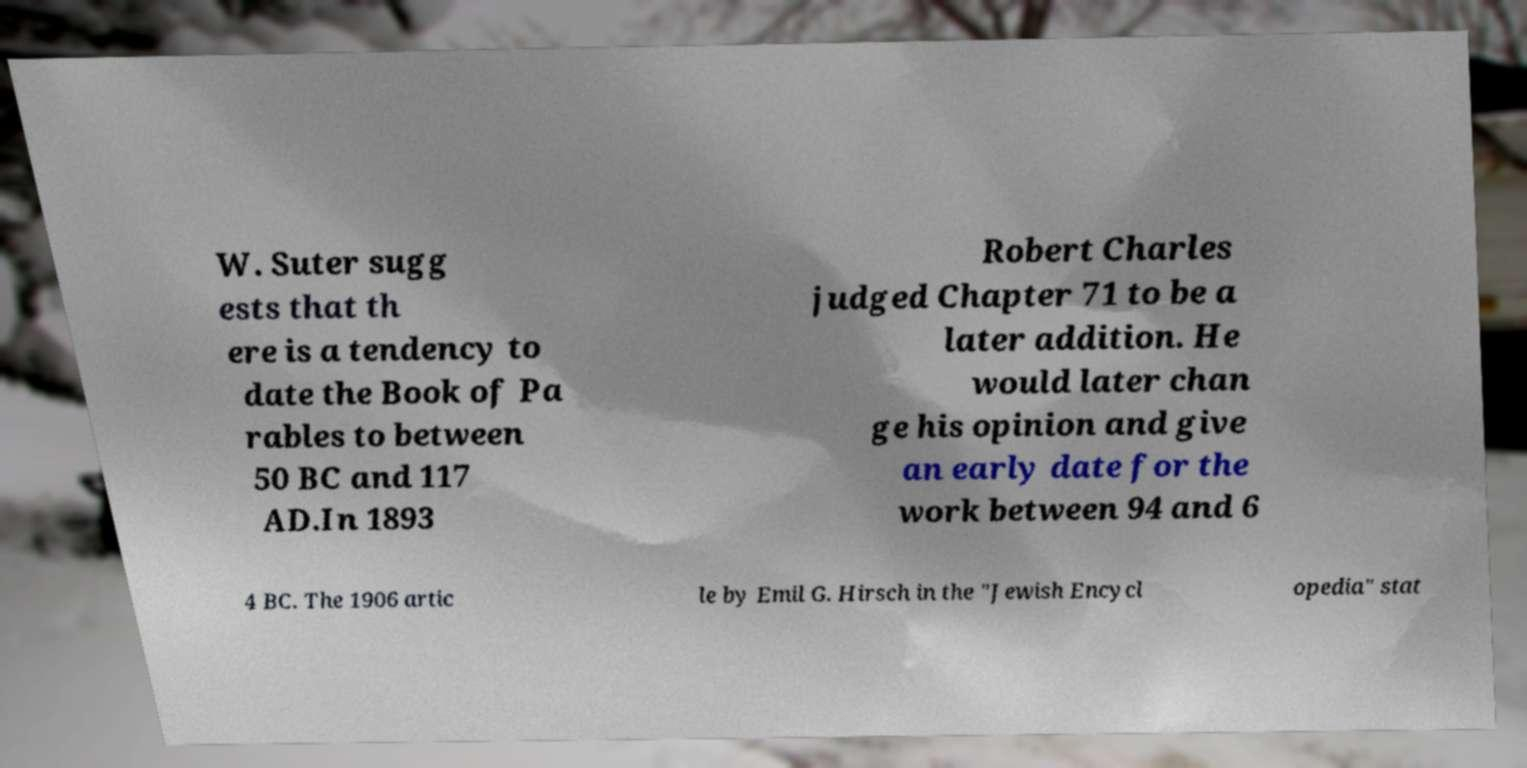Can you read and provide the text displayed in the image?This photo seems to have some interesting text. Can you extract and type it out for me? W. Suter sugg ests that th ere is a tendency to date the Book of Pa rables to between 50 BC and 117 AD.In 1893 Robert Charles judged Chapter 71 to be a later addition. He would later chan ge his opinion and give an early date for the work between 94 and 6 4 BC. The 1906 artic le by Emil G. Hirsch in the "Jewish Encycl opedia" stat 